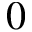<formula> <loc_0><loc_0><loc_500><loc_500>0</formula> 